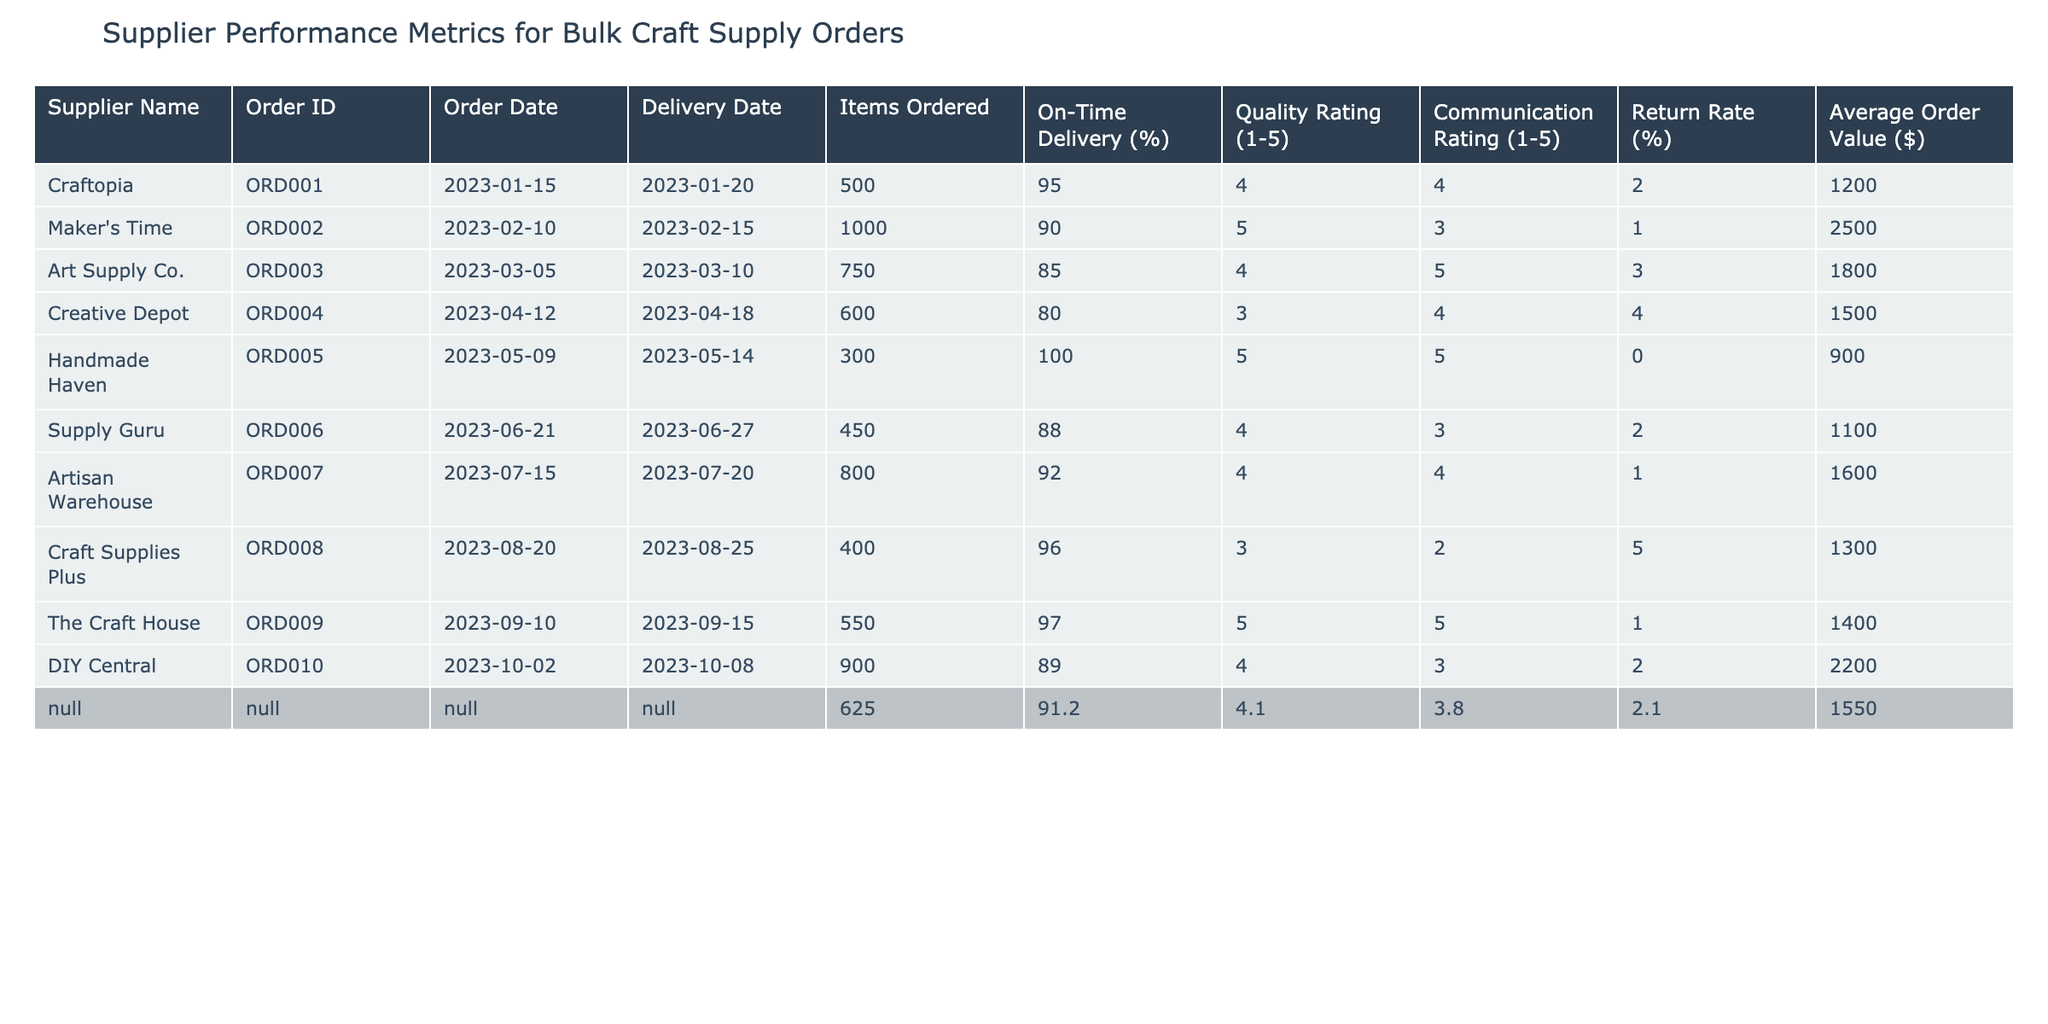What is the average on-time delivery percentage among all suppliers? To find the average on-time delivery percentage, add the on-time delivery percentages of all suppliers (95 + 90 + 85 + 80 + 100 + 88 + 92 + 96 + 97 + 89 = 911) and divide it by the total number of suppliers (10). Therefore, 911 / 10 = 91.1.
Answer: 91.1 Which supplier has the highest quality rating? The quality ratings for each supplier are as follows: Craftopia (4), Maker's Time (5), Art Supply Co. (4), Creative Depot (3), Handmade Haven (5), Supply Guru (4), Artisan Warehouse (4), Craft Supplies Plus (3), The Craft House (5), and DIY Central (4). The maximum rating is 5, held by Maker's Time, Handmade Haven, and The Craft House.
Answer: Maker's Time, Handmade Haven, and The Craft House What is the return rate for Supply Guru? Referring to the table, the return rate for Supply Guru is listed as 2%.
Answer: 2% Is Handmade Haven known for high quality based on its ratings? Handmade Haven has a quality rating of 5, which is the highest possible score. This indicates that it is known for high-quality supplies based on the given rating system.
Answer: Yes What is the difference in average order value between the supplier with the lowest and highest average order value? The average order values are as follows: The lowest is Handmade Haven with $900 and the highest is Maker's Time with $2500. The difference is calculated as $2500 - $900 = $1600.
Answer: $1600 